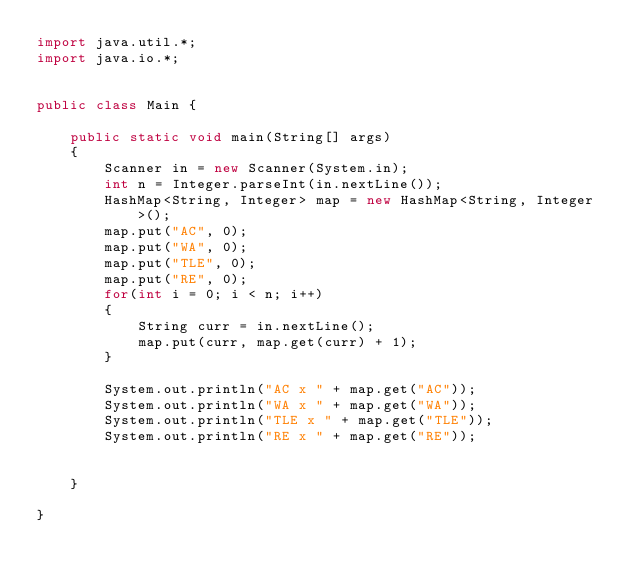<code> <loc_0><loc_0><loc_500><loc_500><_Java_>import java.util.*;
import java.io.*;


public class Main {

	public static void main(String[] args) 
	{
		Scanner in = new Scanner(System.in);
		int n = Integer.parseInt(in.nextLine());
		HashMap<String, Integer> map = new HashMap<String, Integer>();
		map.put("AC", 0);
		map.put("WA", 0);
		map.put("TLE", 0);
		map.put("RE", 0);
		for(int i = 0; i < n; i++)
		{
			String curr = in.nextLine();
			map.put(curr, map.get(curr) + 1);
		}
		
		System.out.println("AC x " + map.get("AC"));
		System.out.println("WA x " + map.get("WA"));
		System.out.println("TLE x " + map.get("TLE"));
		System.out.println("RE x " + map.get("RE"));
		

	}

}</code> 